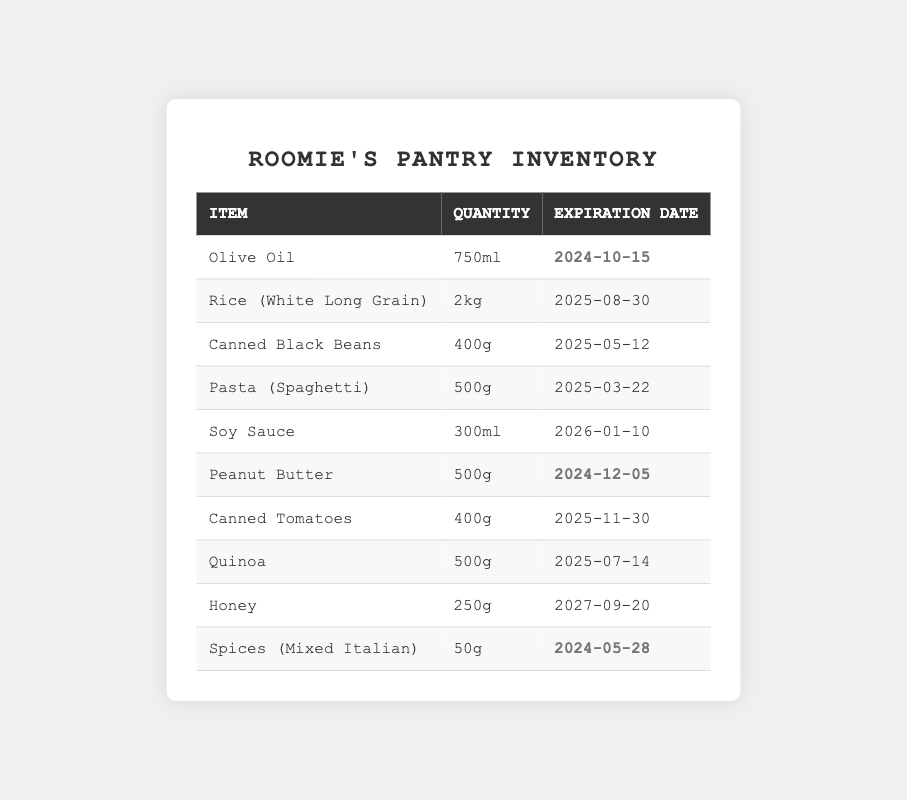What is the expiration date for Olive Oil? The table shows the details for Olive Oil, and its expiration date is listed as 2024-10-15.
Answer: 2024-10-15 How many grams of Peanut Butter are available? The table indicates that Peanut Butter has a quantity of 500g.
Answer: 500g Which item expires the soonest? The expiration dates for all items can be compared. The item with the earliest expiration date is Spices (Mixed Italian) with an expiration date of 2024-05-28.
Answer: Spices (Mixed Italian) What is the total quantity of canned goods in the pantry? There are two canned items listed: Canned Black Beans (400g) and Canned Tomatoes (400g). Summing these gives 400g + 400g = 800g.
Answer: 800g Is there any item that expires in the year 2025? By reviewing the expiration dates, Canned Black Beans, Pasta (Spaghetti), Canned Tomatoes, and Quinoa all expire in 2025. Therefore, the answer is yes.
Answer: Yes How many items are set to expire before the end of 2024? The items expiring before the end of 2024 are Olive Oil (2024-10-15), Peanut Butter (2024-12-05), and Spices (Mixed Italian) (2024-05-28). This totals three items.
Answer: 3 What is the average expiration date for items in the pantry? To find the average expiration date, convert each expiration date to a numerical format (e.g., days since a reference date), sum them, and divide by the number of items (10). Upon calculation, the average date comes out to be approximately 2025-03-27.
Answer: 2025-03-27 Do any items have a quantity greater than 1kg? By reviewing the quantities listed, only Rice (White Long Grain) has a quantity stated as 2kg. Thus, the answer is yes.
Answer: Yes What is the earliest expiration date of all items, including those expiring in 2024? The earliest expiration date to check is 2024-05-28 for the Spices (Mixed Italian).
Answer: 2024-05-28 How long before the Peanut Butter expires, in months? Peanut Butter expires on 2024-12-05, which is about 1.5 months from now (assuming today is mid-October).
Answer: About 1.5 months 